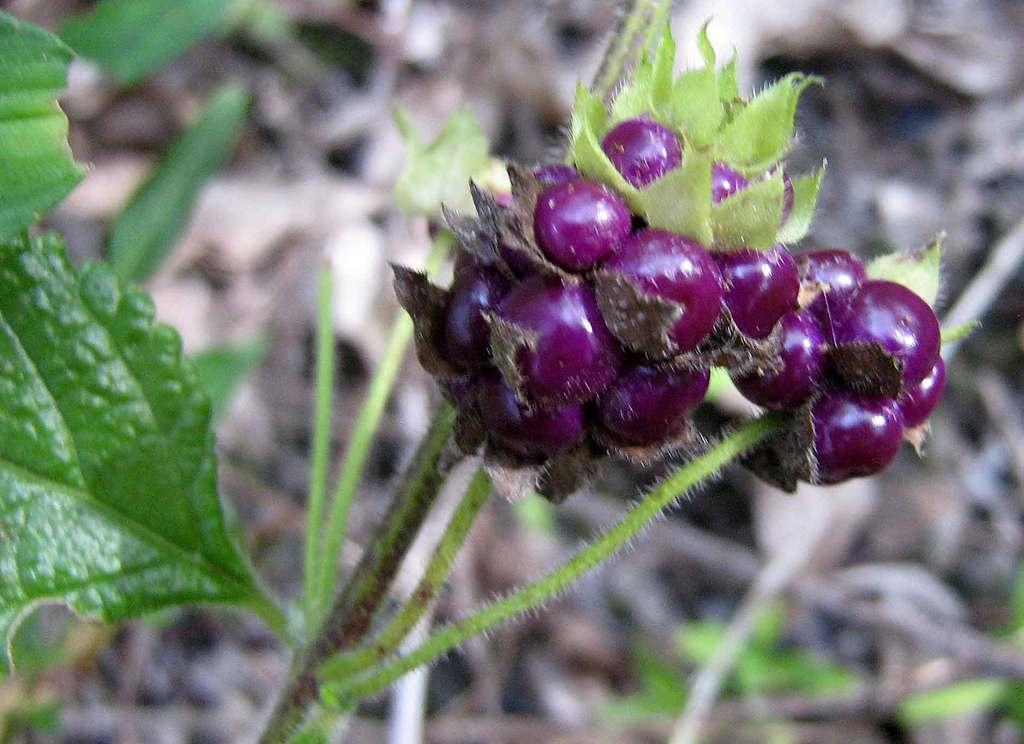Could you give a brief overview of what you see in this image? In this picture we can see fruits and leaves, there is a blurry background. 